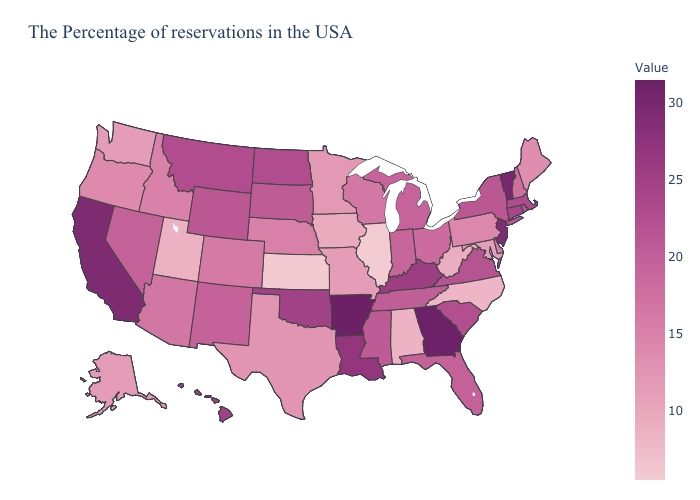Does Massachusetts have the lowest value in the USA?
Keep it brief. No. Does Kentucky have the lowest value in the South?
Quick response, please. No. Among the states that border Minnesota , which have the lowest value?
Quick response, please. Iowa. Does Illinois have the lowest value in the USA?
Keep it brief. Yes. Among the states that border Nevada , does Utah have the lowest value?
Answer briefly. Yes. 